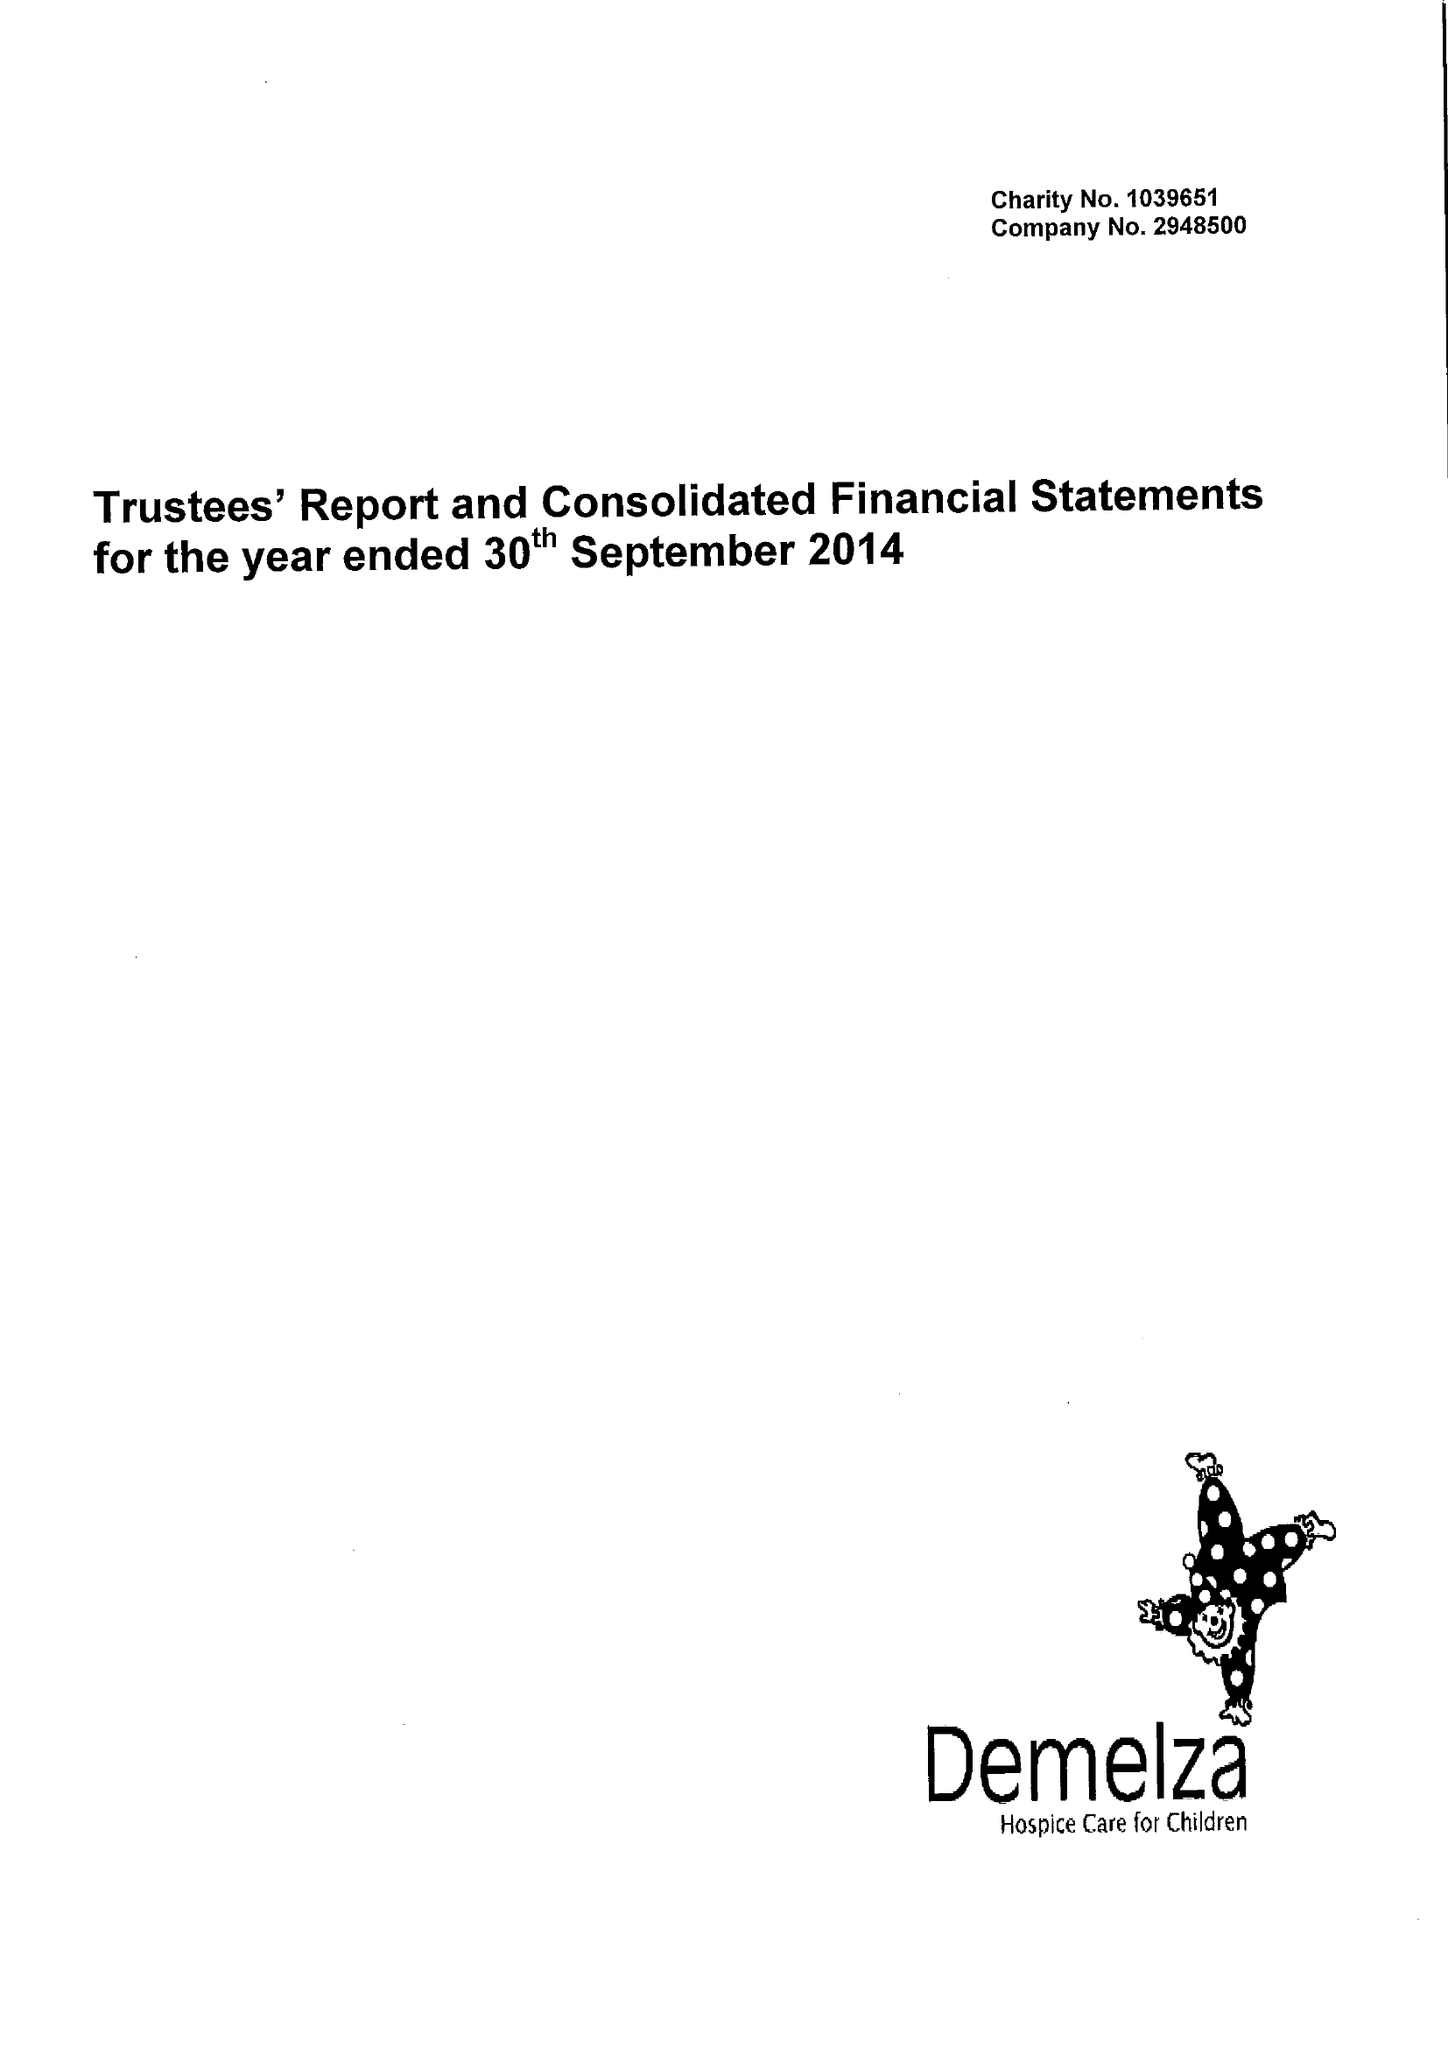What is the value for the income_annually_in_british_pounds?
Answer the question using a single word or phrase. 10498295.00 